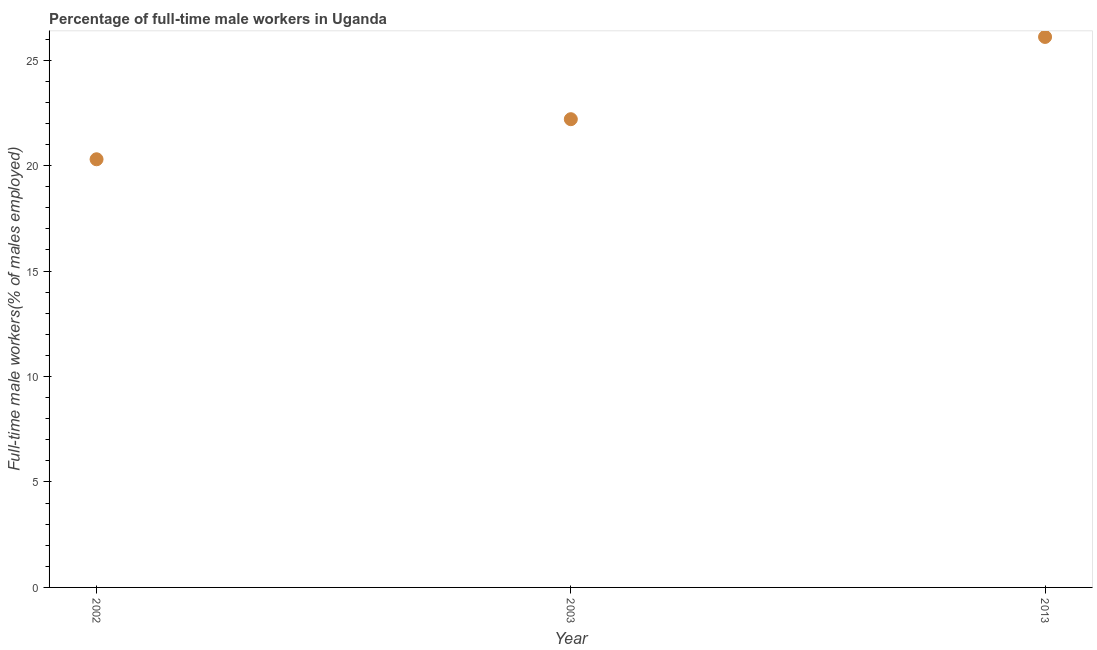What is the percentage of full-time male workers in 2002?
Give a very brief answer. 20.3. Across all years, what is the maximum percentage of full-time male workers?
Your answer should be very brief. 26.1. Across all years, what is the minimum percentage of full-time male workers?
Offer a terse response. 20.3. What is the sum of the percentage of full-time male workers?
Your response must be concise. 68.6. What is the difference between the percentage of full-time male workers in 2003 and 2013?
Keep it short and to the point. -3.9. What is the average percentage of full-time male workers per year?
Your answer should be compact. 22.87. What is the median percentage of full-time male workers?
Keep it short and to the point. 22.2. Do a majority of the years between 2013 and 2003 (inclusive) have percentage of full-time male workers greater than 6 %?
Make the answer very short. No. What is the ratio of the percentage of full-time male workers in 2003 to that in 2013?
Keep it short and to the point. 0.85. Is the percentage of full-time male workers in 2002 less than that in 2013?
Offer a terse response. Yes. What is the difference between the highest and the second highest percentage of full-time male workers?
Provide a short and direct response. 3.9. What is the difference between the highest and the lowest percentage of full-time male workers?
Make the answer very short. 5.8. In how many years, is the percentage of full-time male workers greater than the average percentage of full-time male workers taken over all years?
Make the answer very short. 1. How many years are there in the graph?
Your answer should be very brief. 3. What is the difference between two consecutive major ticks on the Y-axis?
Provide a succinct answer. 5. Are the values on the major ticks of Y-axis written in scientific E-notation?
Give a very brief answer. No. Does the graph contain any zero values?
Your answer should be compact. No. Does the graph contain grids?
Your response must be concise. No. What is the title of the graph?
Your answer should be compact. Percentage of full-time male workers in Uganda. What is the label or title of the Y-axis?
Make the answer very short. Full-time male workers(% of males employed). What is the Full-time male workers(% of males employed) in 2002?
Offer a very short reply. 20.3. What is the Full-time male workers(% of males employed) in 2003?
Your answer should be compact. 22.2. What is the Full-time male workers(% of males employed) in 2013?
Your answer should be compact. 26.1. What is the difference between the Full-time male workers(% of males employed) in 2002 and 2013?
Your response must be concise. -5.8. What is the ratio of the Full-time male workers(% of males employed) in 2002 to that in 2003?
Offer a terse response. 0.91. What is the ratio of the Full-time male workers(% of males employed) in 2002 to that in 2013?
Offer a very short reply. 0.78. What is the ratio of the Full-time male workers(% of males employed) in 2003 to that in 2013?
Provide a short and direct response. 0.85. 